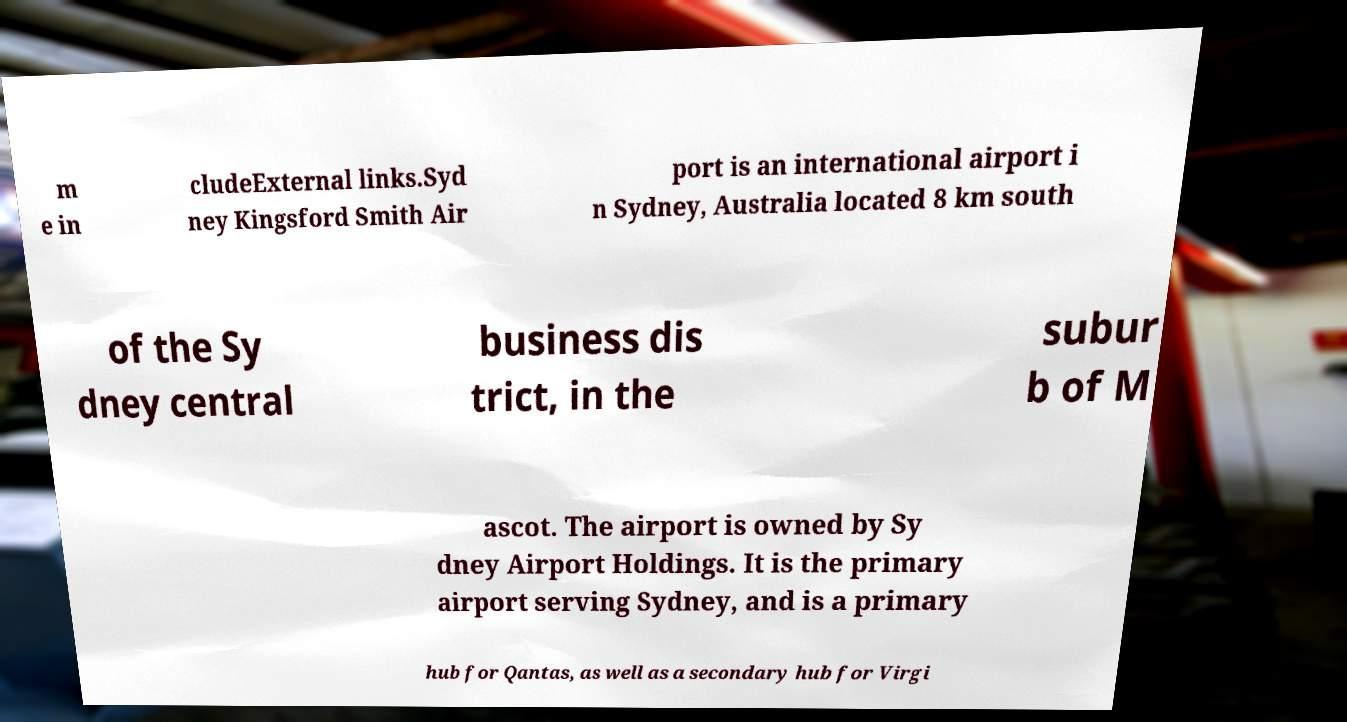Please identify and transcribe the text found in this image. m e in cludeExternal links.Syd ney Kingsford Smith Air port is an international airport i n Sydney, Australia located 8 km south of the Sy dney central business dis trict, in the subur b of M ascot. The airport is owned by Sy dney Airport Holdings. It is the primary airport serving Sydney, and is a primary hub for Qantas, as well as a secondary hub for Virgi 